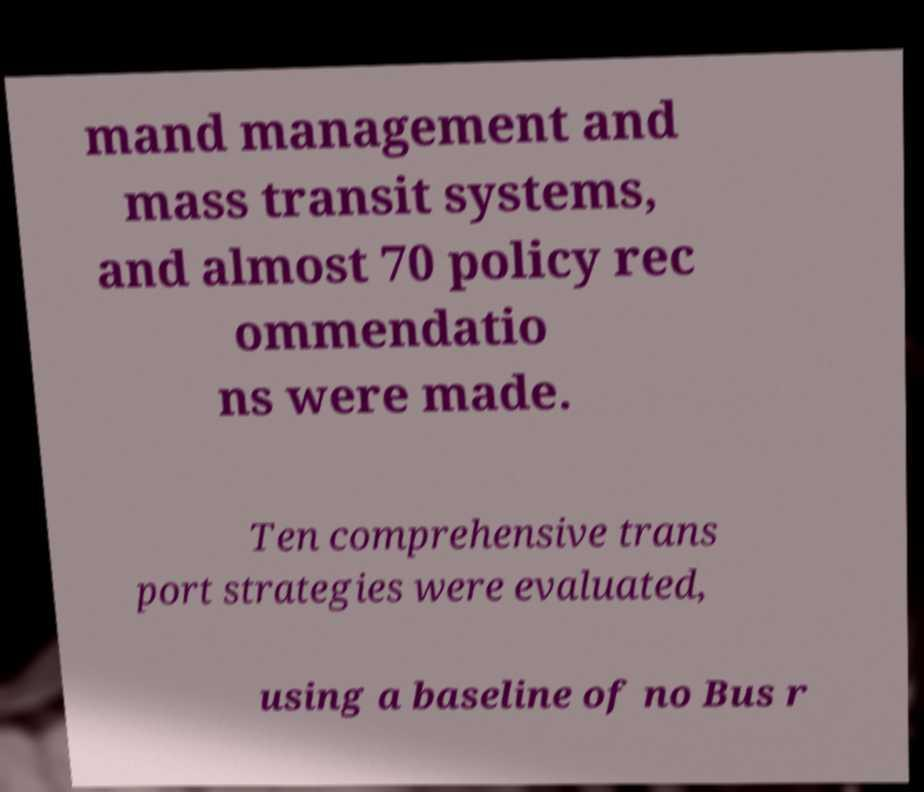What messages or text are displayed in this image? I need them in a readable, typed format. mand management and mass transit systems, and almost 70 policy rec ommendatio ns were made. Ten comprehensive trans port strategies were evaluated, using a baseline of no Bus r 